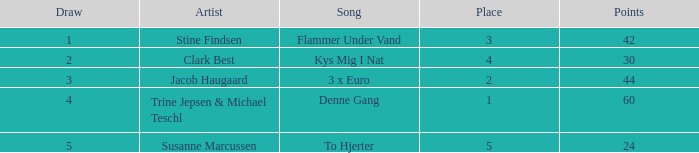In which draw do the points surpass 44 and the rank is above 1? None. 